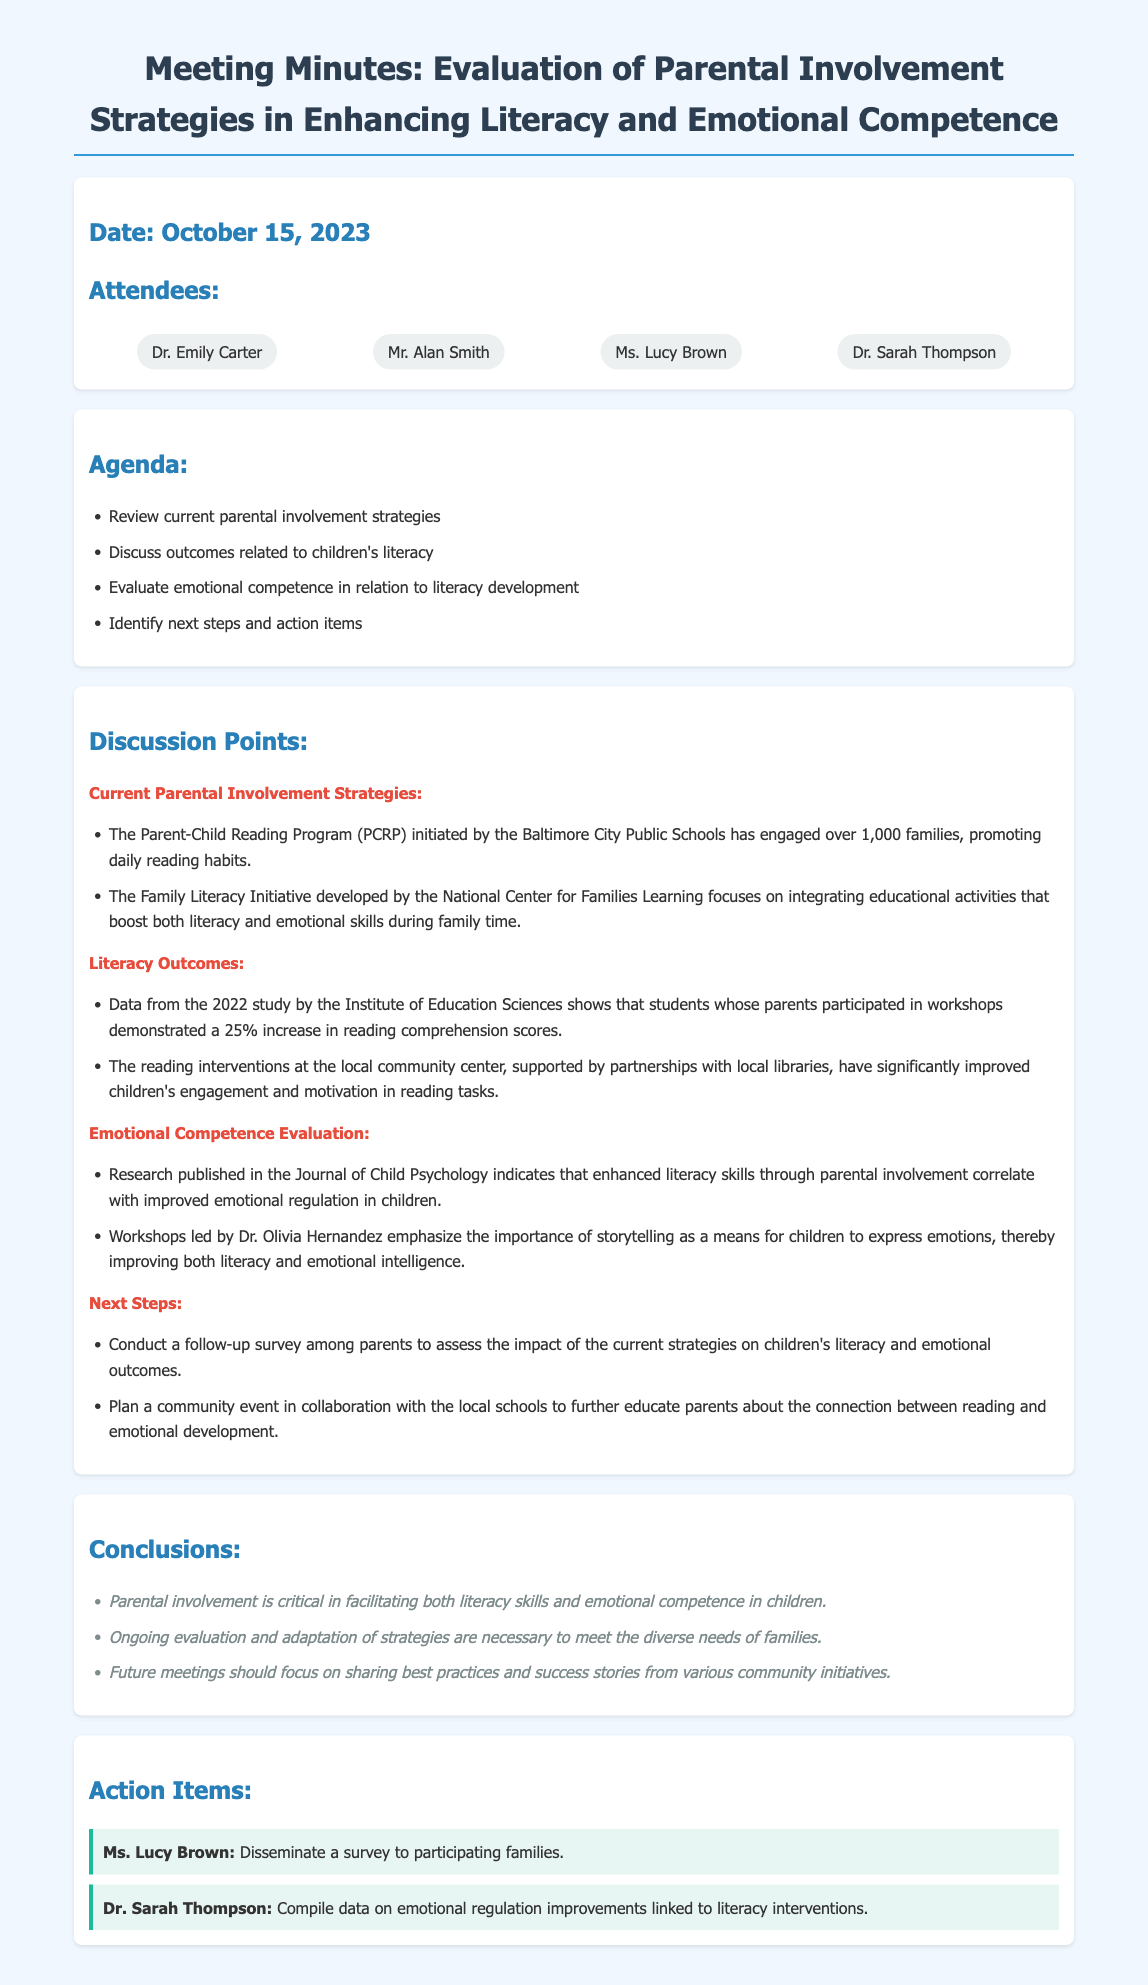What is the date of the meeting? The date is specified at the beginning of the document under the date section.
Answer: October 15, 2023 Who initiated the Parent-Child Reading Program? The document attributes the initiation of the program to the Baltimore City Public Schools.
Answer: Baltimore City Public Schools What percentage increase in reading comprehension scores was noted in the study? The increase is stated in the section discussing literacy outcomes, specifically from a 2022 study.
Answer: 25% What is the focus of the Family Literacy Initiative? The focus of the initiative is outlined in the related discussion point about current parental involvement strategies.
Answer: Integrating educational activities that boost both literacy and emotional skills Which research published indicated a correlation between literacy skills and emotional regulation? The document specifies the source of this research under the emotional competence evaluation section.
Answer: Journal of Child Psychology What is an action item assigned to Ms. Lucy Brown? The action item related to Ms. Lucy Brown is detailed in the action items section of the document.
Answer: Disseminate a survey to participating families What should future meetings focus on? This is mentioned in the conclusions section, outlining the focus areas for future meetings.
Answer: Sharing best practices and success stories from various community initiatives How many families have engaged in the Parent-Child Reading Program? The number of families engaged is given in the discussion points about current parental involvement strategies.
Answer: Over 1,000 families 